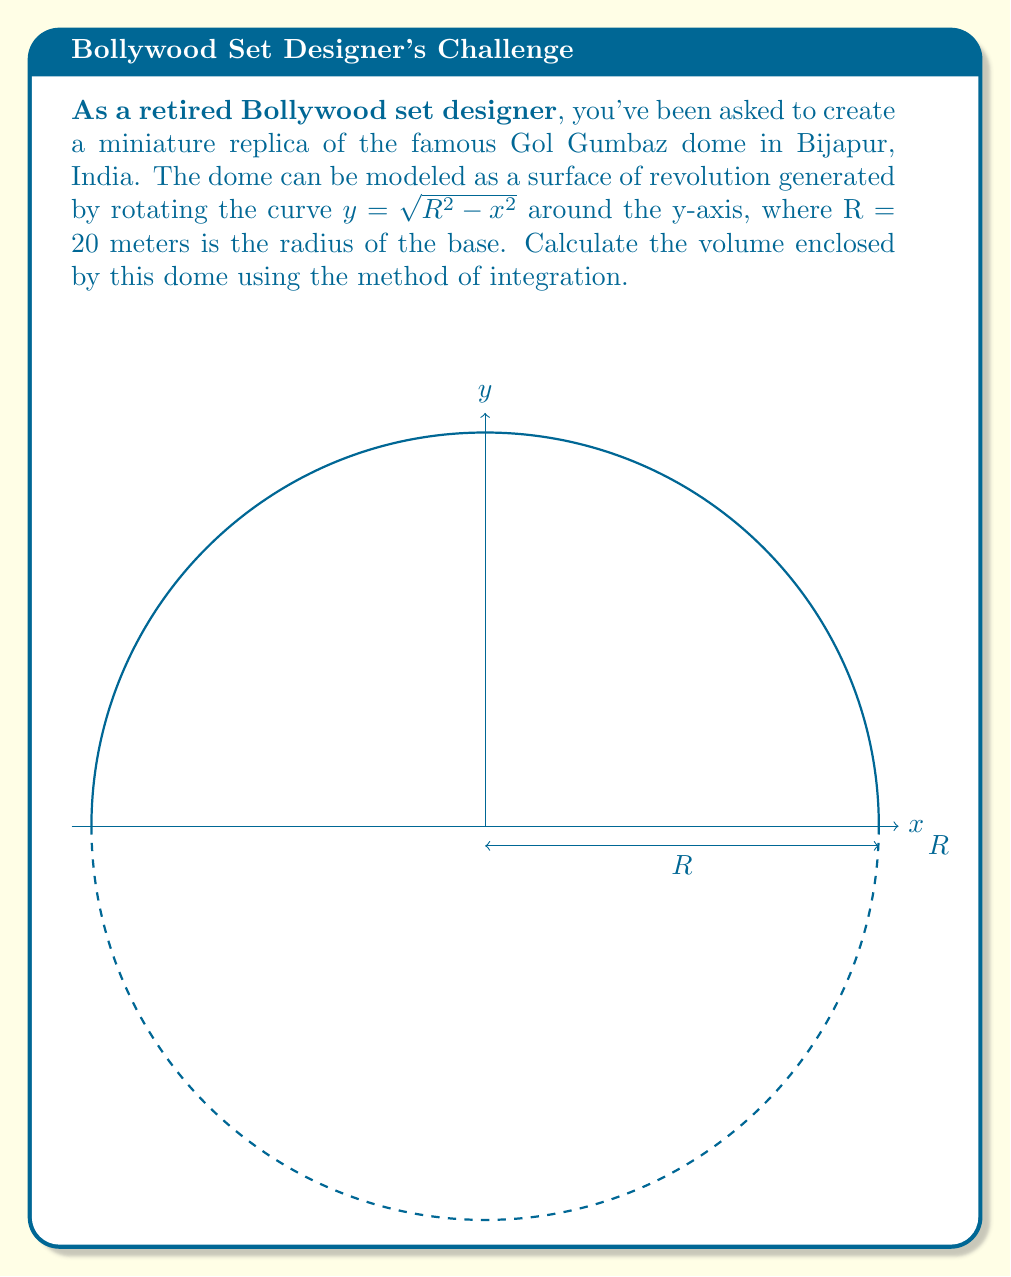Give your solution to this math problem. To solve this problem, we'll use the method of integration for volumes of revolution around the y-axis. The steps are as follows:

1) The volume of a solid of revolution around the y-axis is given by the formula:

   $$V = \pi \int_a^b [f^{-1}(y)]^2 dy$$

   where $f^{-1}(y)$ is the inverse function of $y = f(x)$.

2) In our case, $y = \sqrt{R^2 - x^2}$. We need to express x in terms of y:

   $$x^2 = R^2 - y^2$$
   $$x = \pm\sqrt{R^2 - y^2}$$

   We'll use the positive value as we're interested in the volume.

3) The limits of integration will be from y = 0 (base of the dome) to y = R (top of the dome).

4) Substituting into our volume formula:

   $$V = \pi \int_0^R (R^2 - y^2) dy$$

5) Expand the integrand:

   $$V = \pi \int_0^R (R^2 - y^2) dy = \pi [R^2y - \frac{y^3}{3}]_0^R$$

6) Evaluate the integral:

   $$V = \pi [(R^3 - \frac{R^3}{3}) - (0 - 0)]$$
   $$V = \pi R^3 (\frac{2}{3})$$

7) Substitute R = 20:

   $$V = \pi (20^3) (\frac{2}{3}) = \frac{16000\pi}{3} \approx 16755.16 \text{ cubic meters}$$
Answer: $\frac{16000\pi}{3}$ cubic meters 